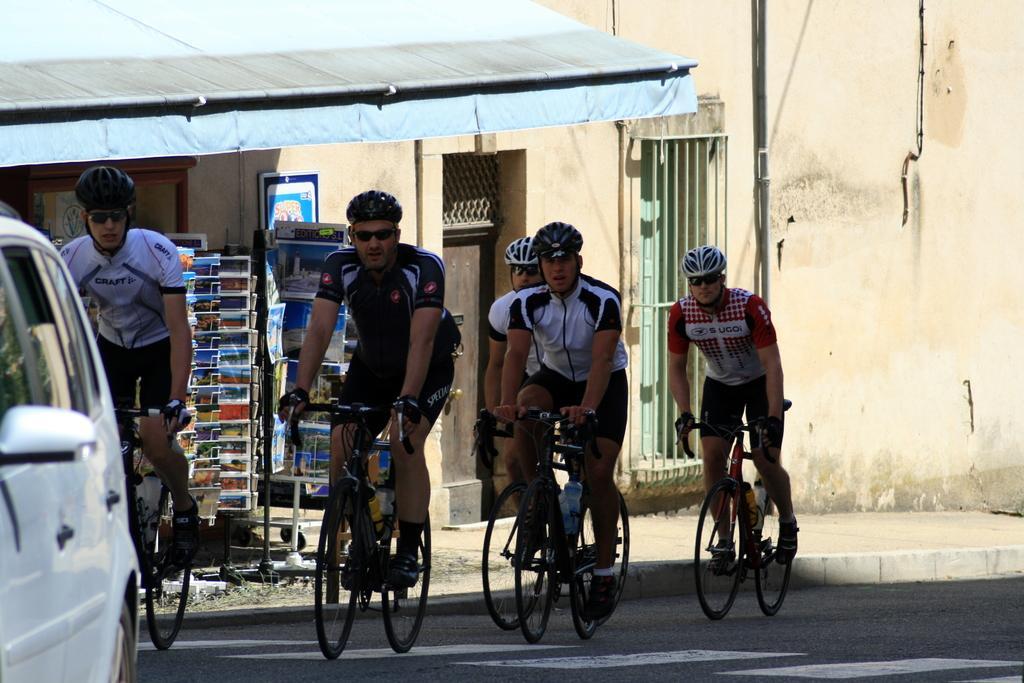In one or two sentences, can you explain what this image depicts? The image is taken on the road. There are people riding bicycles on the road. On the left there is a car. In the background there is a building. 